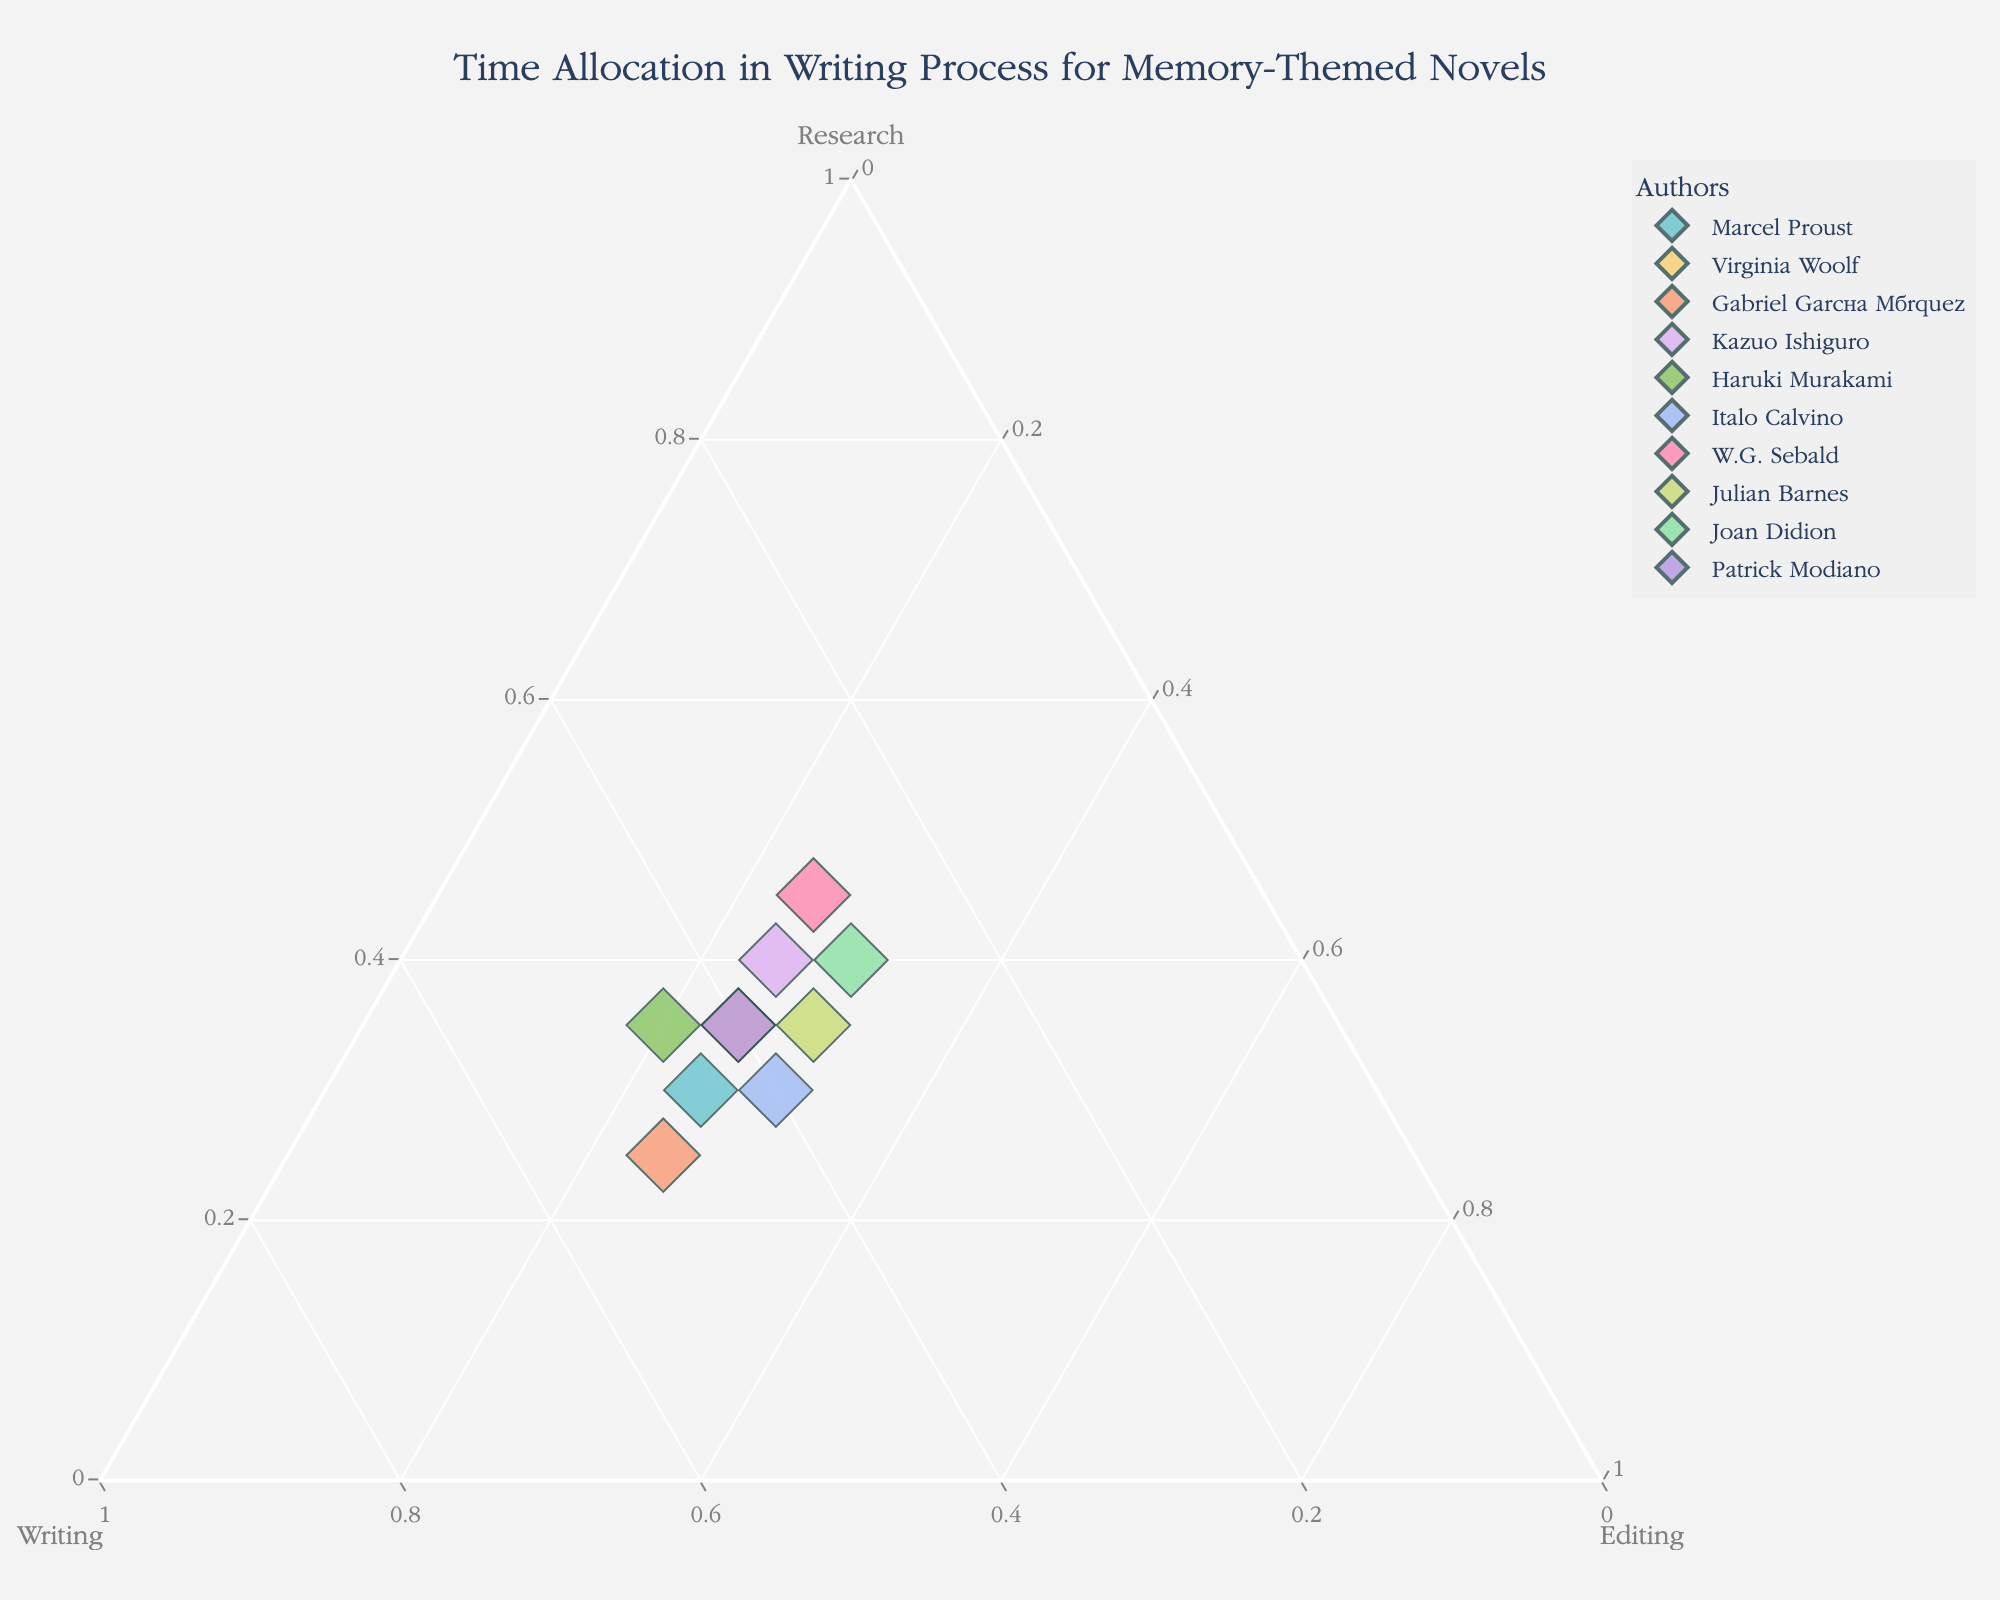What is the title of the figure? The title is usually displayed at the top of the figure.
Answer: Time Allocation in Writing Process for Memory-Themed Novels How many authors are represented in the figure? Each author corresponds to a data point on the plot. By counting the points, you can determine the number of authors.
Answer: 10 Which author's process places the most emphasis on research? Look for the data point closest to the "Research" vertex of the ternary plot.
Answer: W.G. Sebald Which author has the most balanced time allocation among research, writing, and editing? Identify the point closest to the center of the triangle, where the percentages of research, writing, and editing are almost equal.
Answer: Julian Barnes What is the total percentage of time allocated to writing for Haruki Murakami? Identify Haruki Murakami's data point and check the "Writing" axis value for it.
Answer: 45% Who spends the least amount of time on editing? Identify the point closest to the "Research" or "Writing" edges but furthest from the "Editing" vertex.
Answer: Haruki Murakami What is the combined total time (in percent) allocated to research by Marcel Proust and Virginia Woolf? Sum the values of research for both Marcel Proust (30%) and Virginia Woolf (35%).
Answer: 65% What is the difference in the time allocated to writing between Gabriel García Márquez and Kazuo Ishiguro? Subtract Kazuo Ishiguro's writing time (35%) from Gabriel García Márquez's writing time (50%).
Answer: 15% How does Joan Didion's time allocation for editing compare to that of Julian Barnes? Compare the editing percentages of Joan Didion (30%) and Julian Barnes (30%) to see if they are equal or if one is higher.
Answer: Equal Identify two authors who spend an equal amount of time on writing but differ in other aspects of the process. Find two points with identical values on the writing axis and then compare their research and editing percentages.
Answer: Marcel Proust and Haruki Murakami 